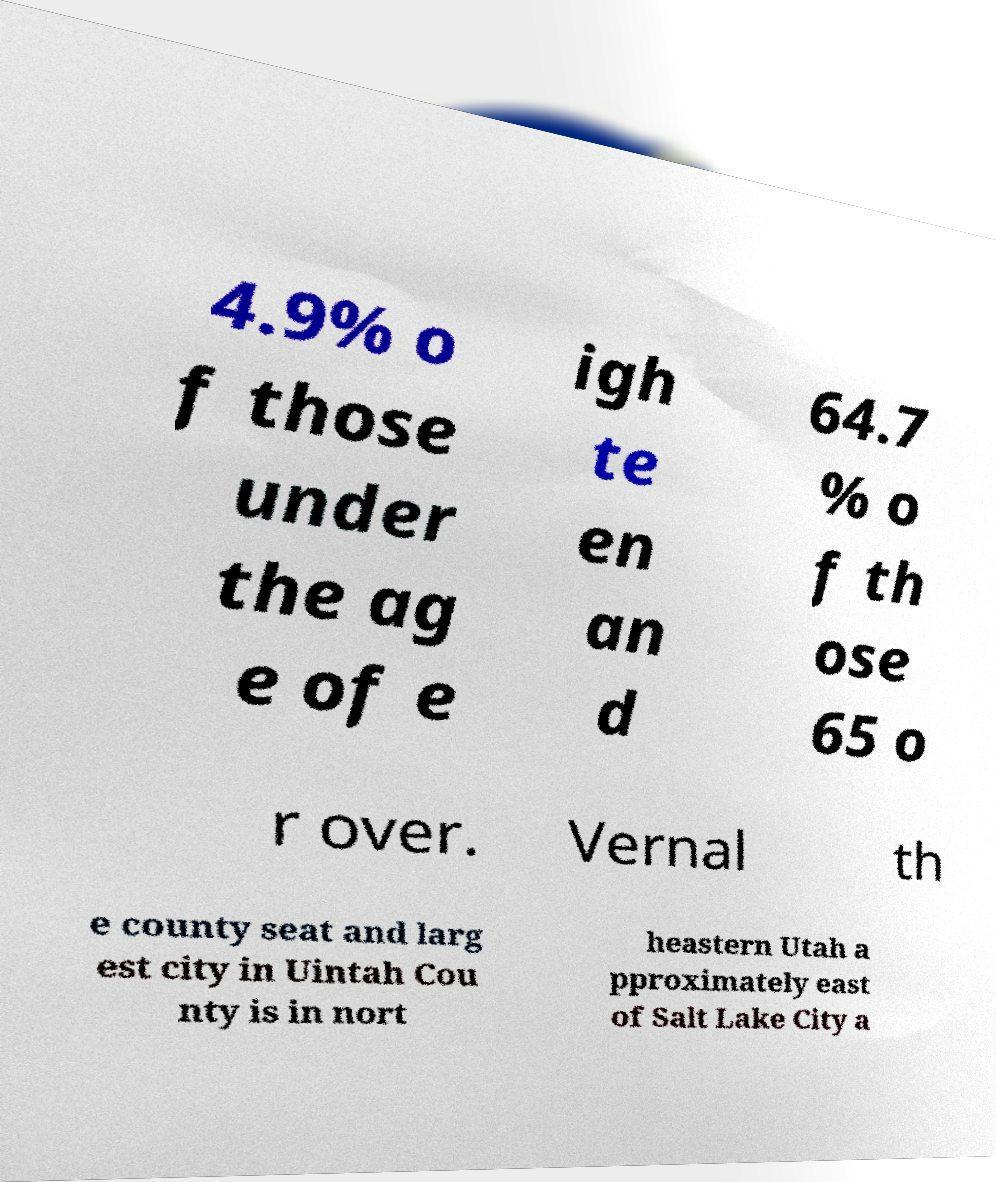Can you read and provide the text displayed in the image?This photo seems to have some interesting text. Can you extract and type it out for me? 4.9% o f those under the ag e of e igh te en an d 64.7 % o f th ose 65 o r over. Vernal th e county seat and larg est city in Uintah Cou nty is in nort heastern Utah a pproximately east of Salt Lake City a 